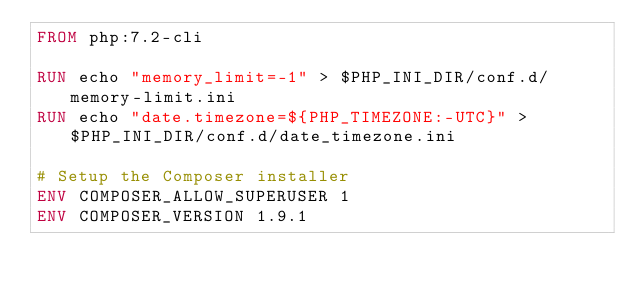Convert code to text. <code><loc_0><loc_0><loc_500><loc_500><_Dockerfile_>FROM php:7.2-cli

RUN echo "memory_limit=-1" > $PHP_INI_DIR/conf.d/memory-limit.ini
RUN echo "date.timezone=${PHP_TIMEZONE:-UTC}" > $PHP_INI_DIR/conf.d/date_timezone.ini

# Setup the Composer installer
ENV COMPOSER_ALLOW_SUPERUSER 1
ENV COMPOSER_VERSION 1.9.1
</code> 